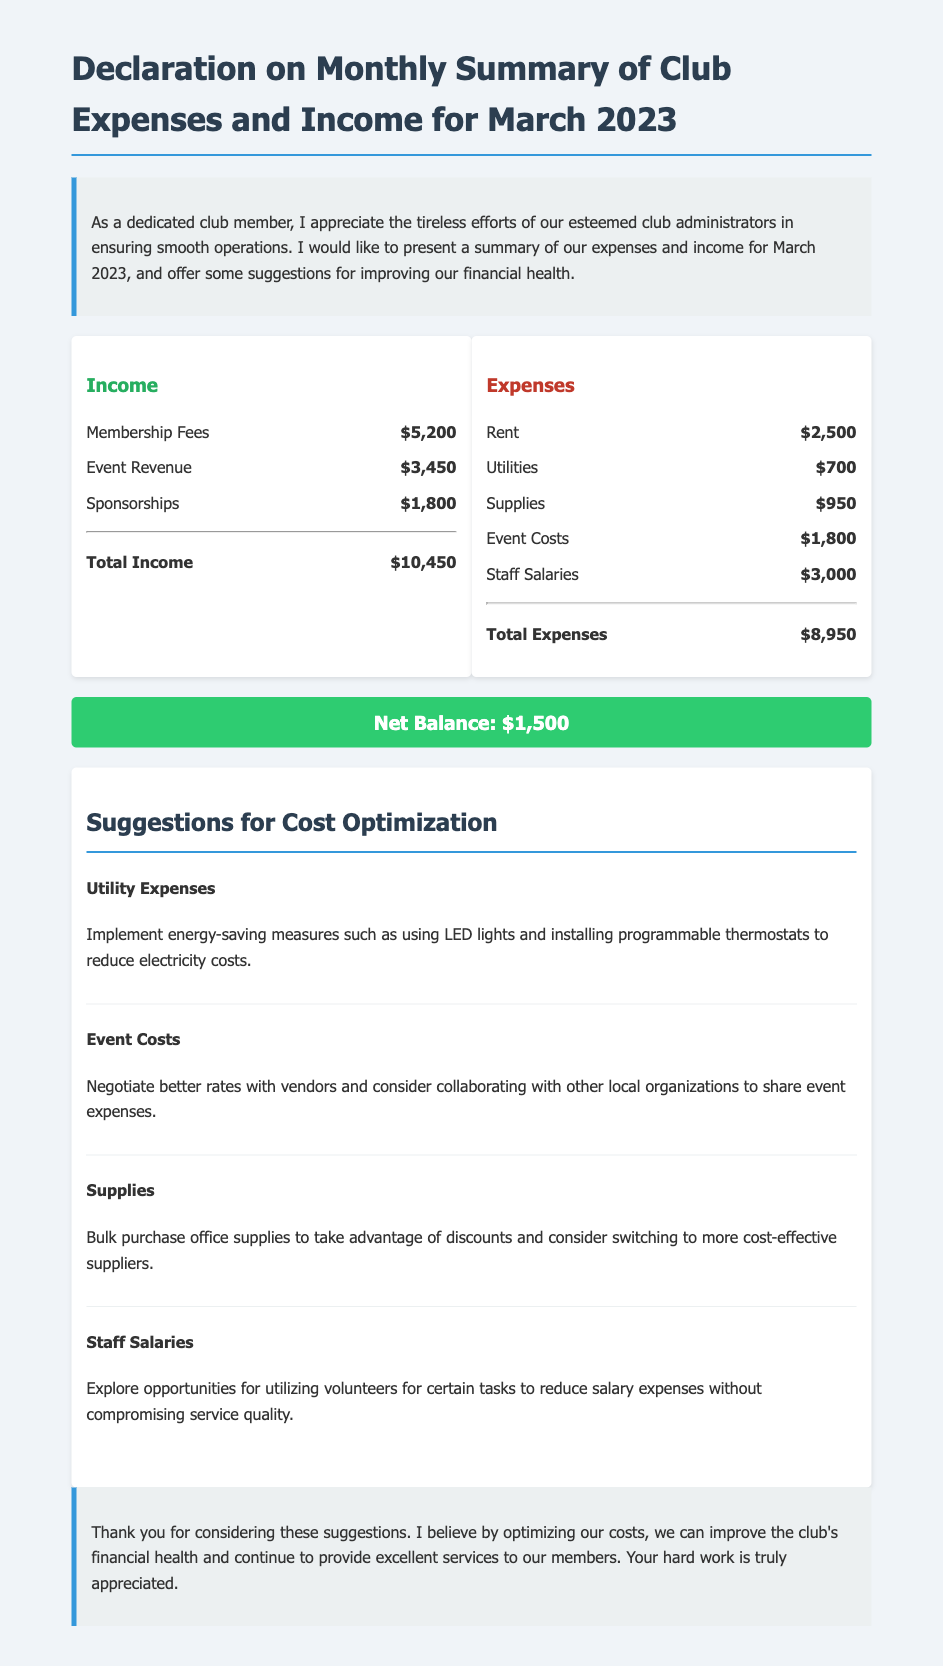What is the total income? The total income is calculated from all income sources listed in the document, which adds up to $5,200 + $3,450 + $1,800.
Answer: $10,450 What are the total expenses? The total expenses are the sum of all expenses mentioned in the document, which is $2,500 + $700 + $950 + $1,800 + $3,000.
Answer: $8,950 What is the net balance? The net balance is the difference between total income and total expenses, which is $10,450 - $8,950.
Answer: $1,500 Which expense category has the highest cost? The expenses have several categories, and the one with the highest cost is Staff Salaries at $3,000.
Answer: Staff Salaries What suggestion is given for optimizing utility expenses? The document suggests implementing energy-saving measures to reduce electricity costs.
Answer: Energy-saving measures How much revenue does sponsorships provide? The document states that the sponsorships contribute $1,800 to the club's income.
Answer: $1,800 What specific measure is suggested to lower event costs? The suggestion includes negotiating better rates with vendors to lower event costs.
Answer: Negotiate better rates How could the club handle supplies costs more effectively? The document suggests bulk purchasing office supplies to take advantage of discounts.
Answer: Bulk purchase office supplies What is the overall purpose of this document? The document serves to summarize the club's financial status for March 2023 and provide cost optimization suggestions.
Answer: Financial summary and suggestions 